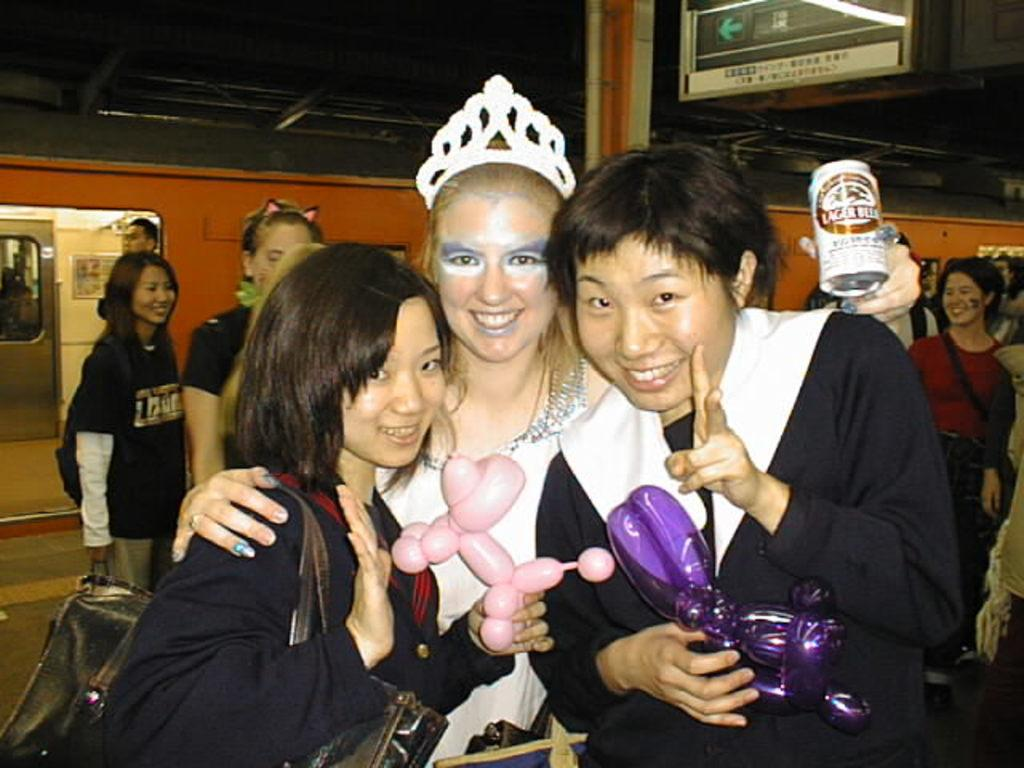What are the three people in the image doing? The three people are holding objects in the image. Can you describe the appearance of the person in the center? The center person is wearing a crown. What can be seen in the background of the image? There are people, a sign board, a train, and rods visible in the background of the image. What type of vacation is the group planning based on the image? There is no indication of a vacation in the image; it simply shows three people holding objects and a background scene. How many steps are visible in the image? There are no steps visible in the image. 